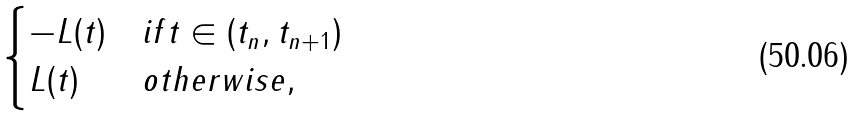Convert formula to latex. <formula><loc_0><loc_0><loc_500><loc_500>\begin{cases} - L ( t ) & i f t \in ( t _ { n } , t _ { n + 1 } ) \\ L ( t ) & o t h e r w i s e , \end{cases}</formula> 